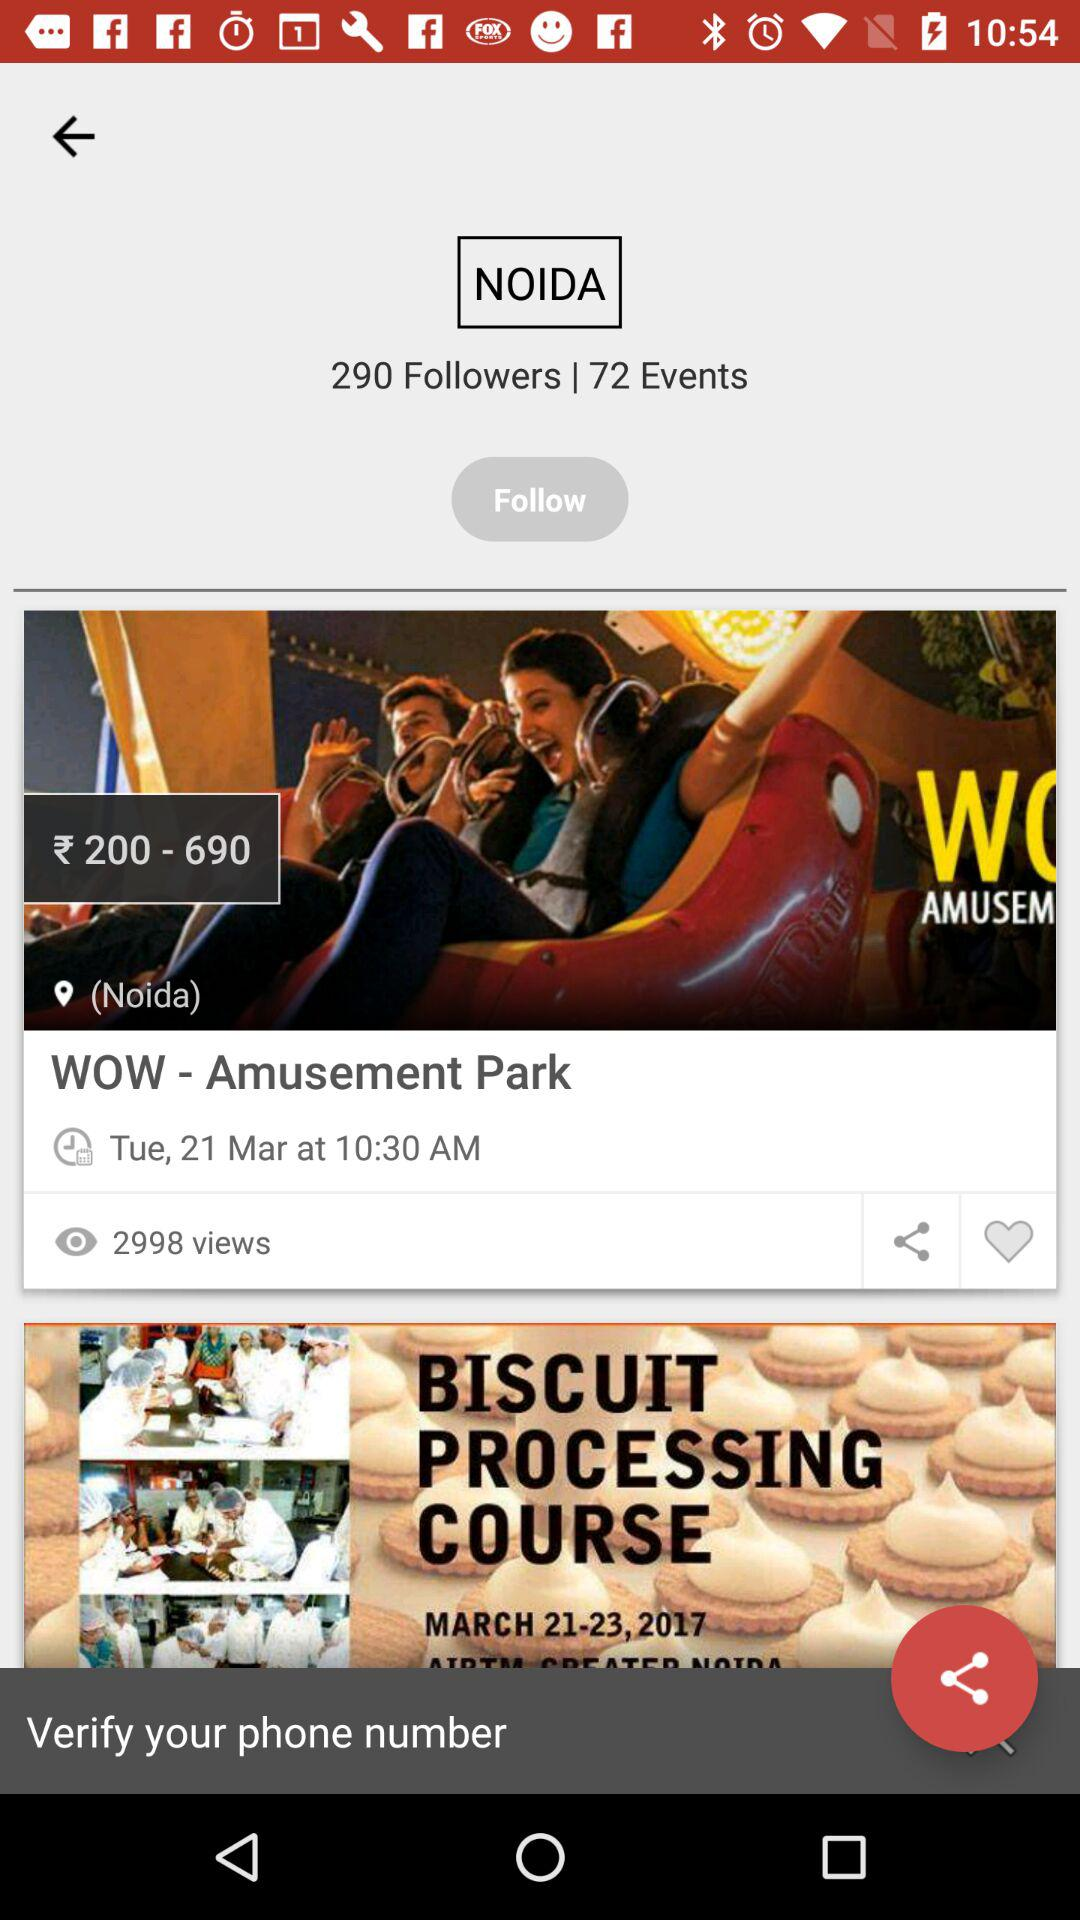What is the date of the "WOW - Amusement Park" event? The date of the "WOW - Amusement Park" event is Tuesday, March 21. 